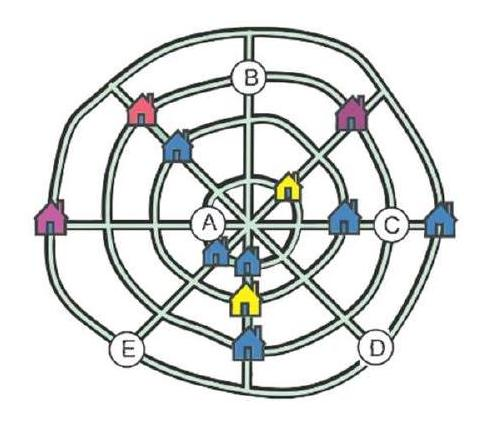Can you explain how the streets are organized in this village? Sure! The village layout consists of four straight streets that interconnect at the center, forming a grid-like pattern. Encircling this grid are four circular streets that create loops around the central area. Every street, whether straight or curved, has exactly three houses situated along it, creating a harmonious and balanced design. 